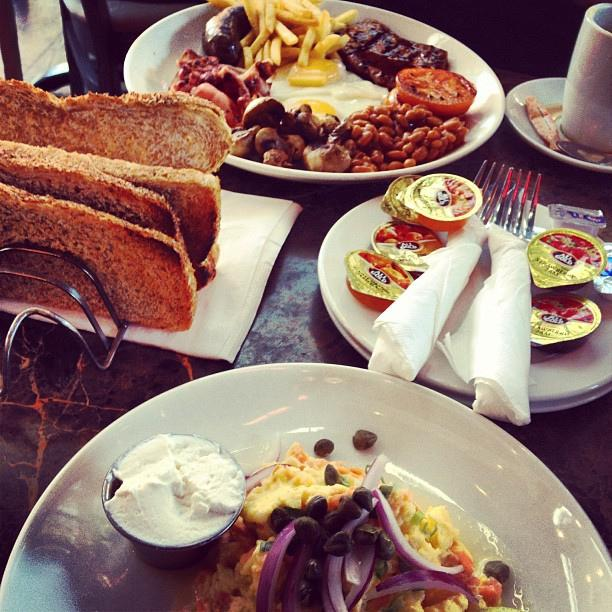What is on the plate with the two wrapped forks? butter 